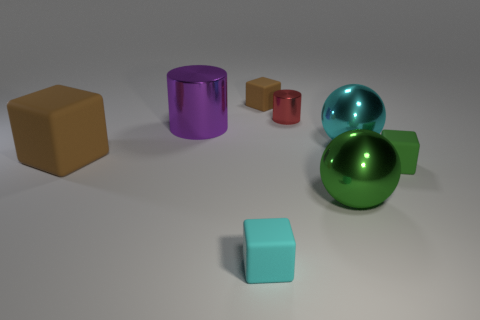Subtract all red blocks. Subtract all purple cylinders. How many blocks are left? 4 Add 2 small metal cylinders. How many objects exist? 10 Subtract all cylinders. How many objects are left? 6 Subtract 0 gray spheres. How many objects are left? 8 Subtract all green rubber objects. Subtract all big green metallic spheres. How many objects are left? 6 Add 1 green objects. How many green objects are left? 3 Add 1 yellow metal cubes. How many yellow metal cubes exist? 1 